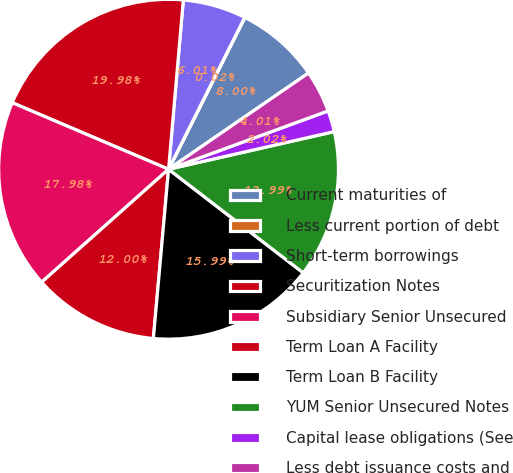Convert chart to OTSL. <chart><loc_0><loc_0><loc_500><loc_500><pie_chart><fcel>Current maturities of<fcel>Less current portion of debt<fcel>Short-term borrowings<fcel>Securitization Notes<fcel>Subsidiary Senior Unsecured<fcel>Term Loan A Facility<fcel>Term Loan B Facility<fcel>YUM Senior Unsecured Notes<fcel>Capital lease obligations (See<fcel>Less debt issuance costs and<nl><fcel>8.0%<fcel>0.02%<fcel>6.01%<fcel>19.98%<fcel>17.98%<fcel>12.0%<fcel>15.99%<fcel>13.99%<fcel>2.02%<fcel>4.01%<nl></chart> 